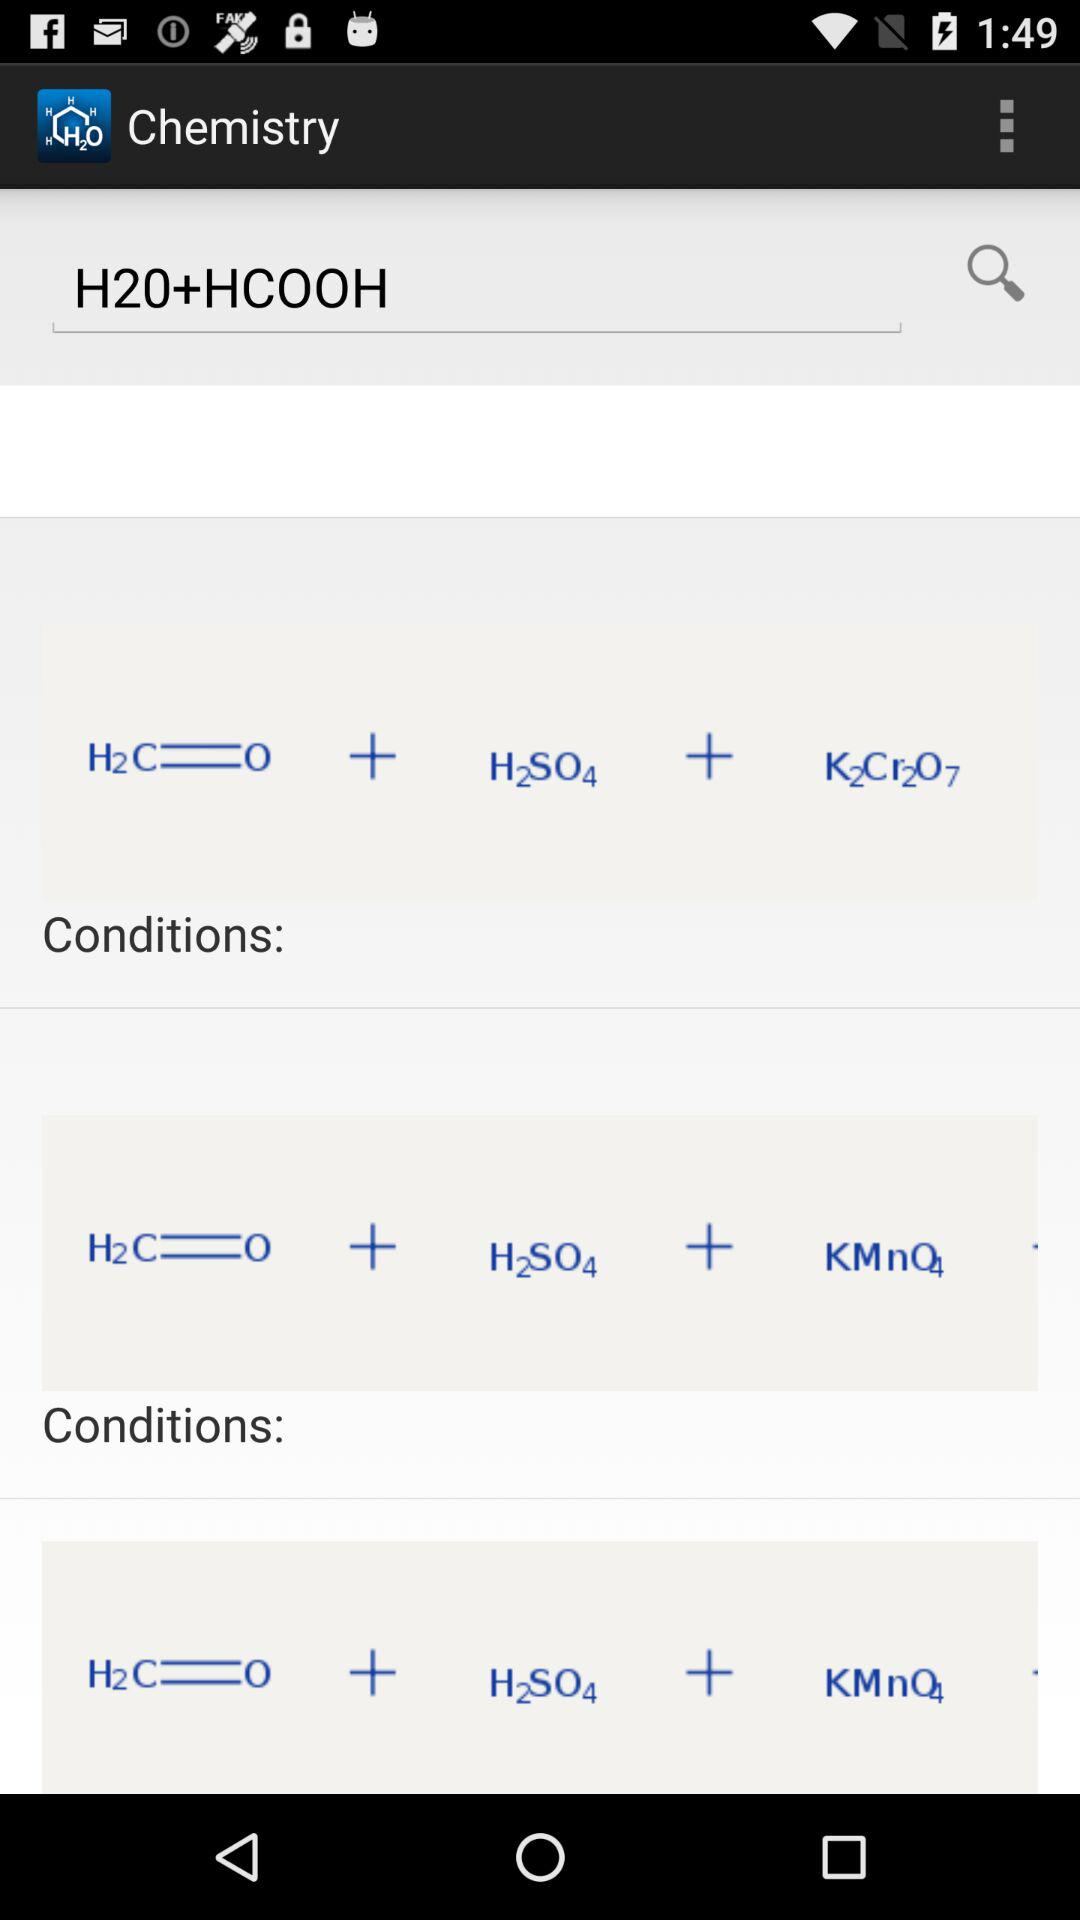What's the application name? The application name is "Chemistry". 